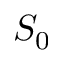Convert formula to latex. <formula><loc_0><loc_0><loc_500><loc_500>S _ { 0 }</formula> 